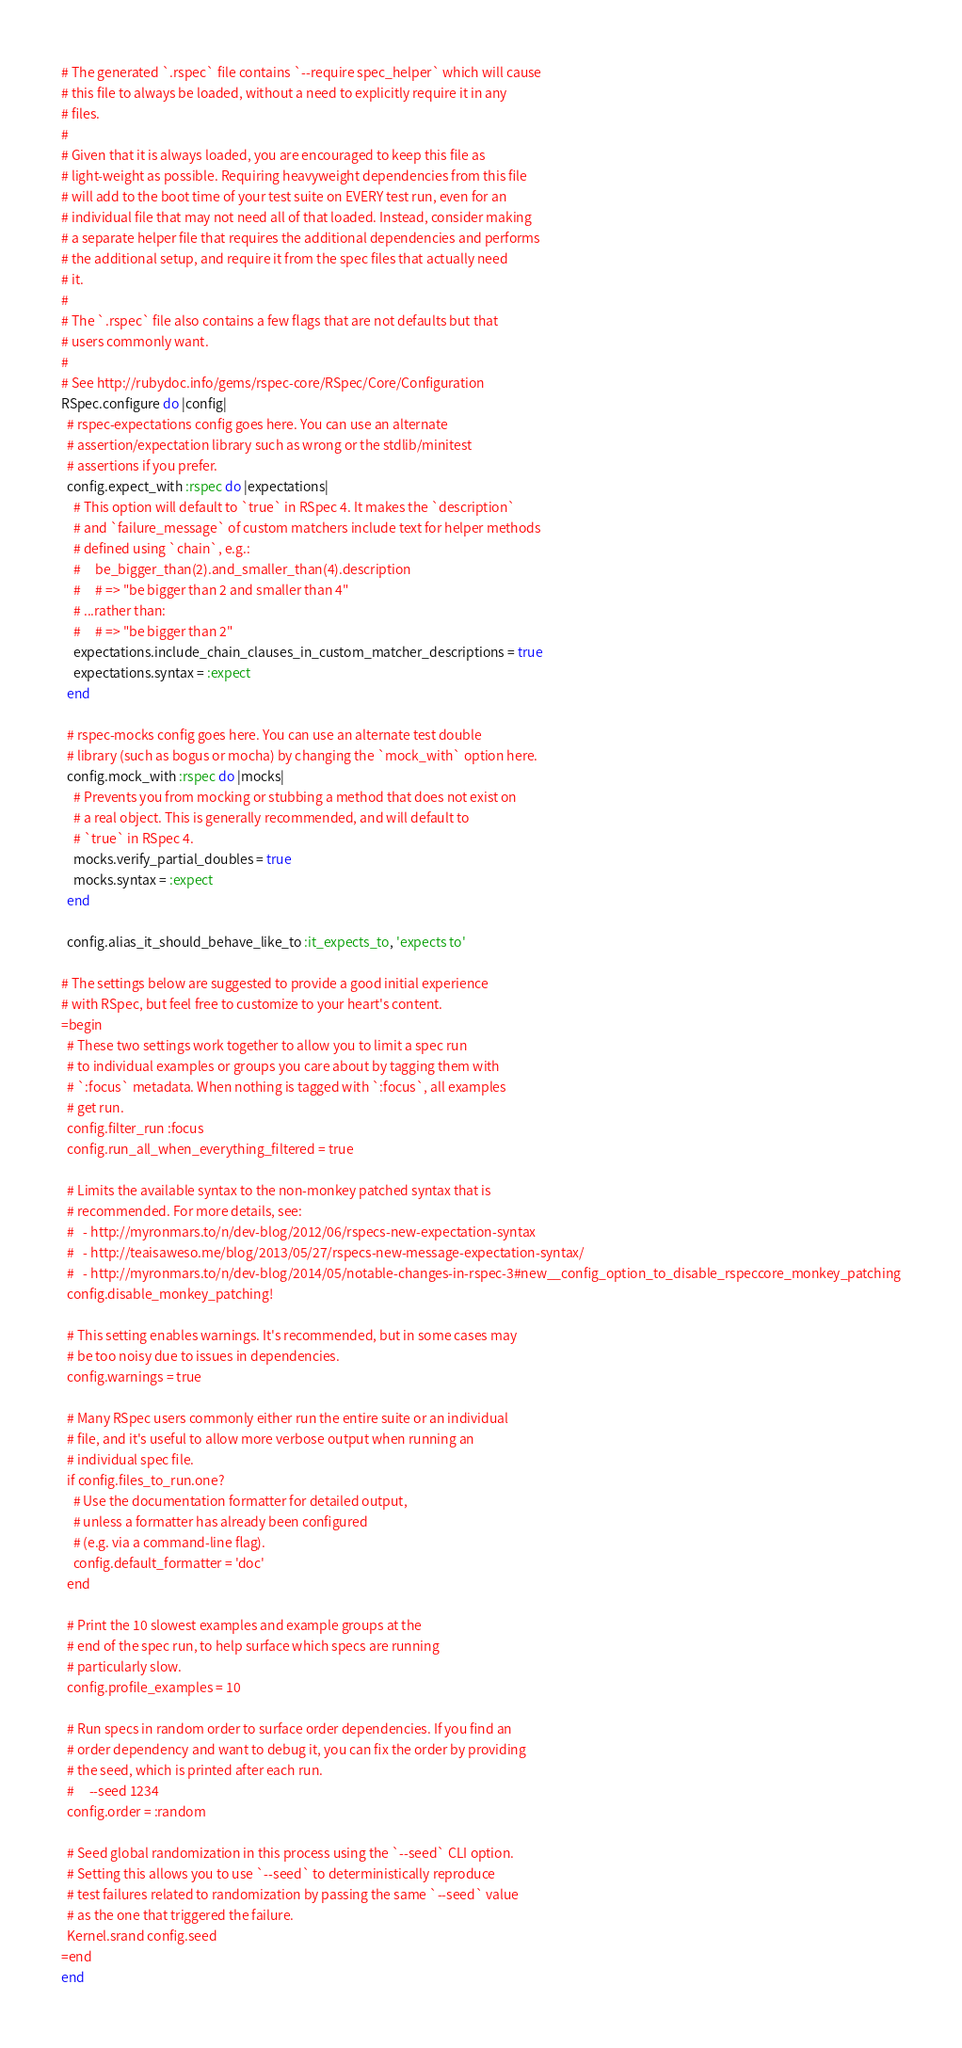Convert code to text. <code><loc_0><loc_0><loc_500><loc_500><_Ruby_># The generated `.rspec` file contains `--require spec_helper` which will cause
# this file to always be loaded, without a need to explicitly require it in any
# files.
#
# Given that it is always loaded, you are encouraged to keep this file as
# light-weight as possible. Requiring heavyweight dependencies from this file
# will add to the boot time of your test suite on EVERY test run, even for an
# individual file that may not need all of that loaded. Instead, consider making
# a separate helper file that requires the additional dependencies and performs
# the additional setup, and require it from the spec files that actually need
# it.
#
# The `.rspec` file also contains a few flags that are not defaults but that
# users commonly want.
#
# See http://rubydoc.info/gems/rspec-core/RSpec/Core/Configuration
RSpec.configure do |config|
  # rspec-expectations config goes here. You can use an alternate
  # assertion/expectation library such as wrong or the stdlib/minitest
  # assertions if you prefer.
  config.expect_with :rspec do |expectations|
    # This option will default to `true` in RSpec 4. It makes the `description`
    # and `failure_message` of custom matchers include text for helper methods
    # defined using `chain`, e.g.:
    #     be_bigger_than(2).and_smaller_than(4).description
    #     # => "be bigger than 2 and smaller than 4"
    # ...rather than:
    #     # => "be bigger than 2"
    expectations.include_chain_clauses_in_custom_matcher_descriptions = true
    expectations.syntax = :expect
  end

  # rspec-mocks config goes here. You can use an alternate test double
  # library (such as bogus or mocha) by changing the `mock_with` option here.
  config.mock_with :rspec do |mocks|
    # Prevents you from mocking or stubbing a method that does not exist on
    # a real object. This is generally recommended, and will default to
    # `true` in RSpec 4.
    mocks.verify_partial_doubles = true
    mocks.syntax = :expect
  end

  config.alias_it_should_behave_like_to :it_expects_to, 'expects to'

# The settings below are suggested to provide a good initial experience
# with RSpec, but feel free to customize to your heart's content.
=begin
  # These two settings work together to allow you to limit a spec run
  # to individual examples or groups you care about by tagging them with
  # `:focus` metadata. When nothing is tagged with `:focus`, all examples
  # get run.
  config.filter_run :focus
  config.run_all_when_everything_filtered = true

  # Limits the available syntax to the non-monkey patched syntax that is
  # recommended. For more details, see:
  #   - http://myronmars.to/n/dev-blog/2012/06/rspecs-new-expectation-syntax
  #   - http://teaisaweso.me/blog/2013/05/27/rspecs-new-message-expectation-syntax/
  #   - http://myronmars.to/n/dev-blog/2014/05/notable-changes-in-rspec-3#new__config_option_to_disable_rspeccore_monkey_patching
  config.disable_monkey_patching!

  # This setting enables warnings. It's recommended, but in some cases may
  # be too noisy due to issues in dependencies.
  config.warnings = true

  # Many RSpec users commonly either run the entire suite or an individual
  # file, and it's useful to allow more verbose output when running an
  # individual spec file.
  if config.files_to_run.one?
    # Use the documentation formatter for detailed output,
    # unless a formatter has already been configured
    # (e.g. via a command-line flag).
    config.default_formatter = 'doc'
  end

  # Print the 10 slowest examples and example groups at the
  # end of the spec run, to help surface which specs are running
  # particularly slow.
  config.profile_examples = 10

  # Run specs in random order to surface order dependencies. If you find an
  # order dependency and want to debug it, you can fix the order by providing
  # the seed, which is printed after each run.
  #     --seed 1234
  config.order = :random

  # Seed global randomization in this process using the `--seed` CLI option.
  # Setting this allows you to use `--seed` to deterministically reproduce
  # test failures related to randomization by passing the same `--seed` value
  # as the one that triggered the failure.
  Kernel.srand config.seed
=end
end
</code> 